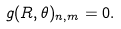Convert formula to latex. <formula><loc_0><loc_0><loc_500><loc_500>g ( R , \theta ) _ { n , m } = 0 .</formula> 